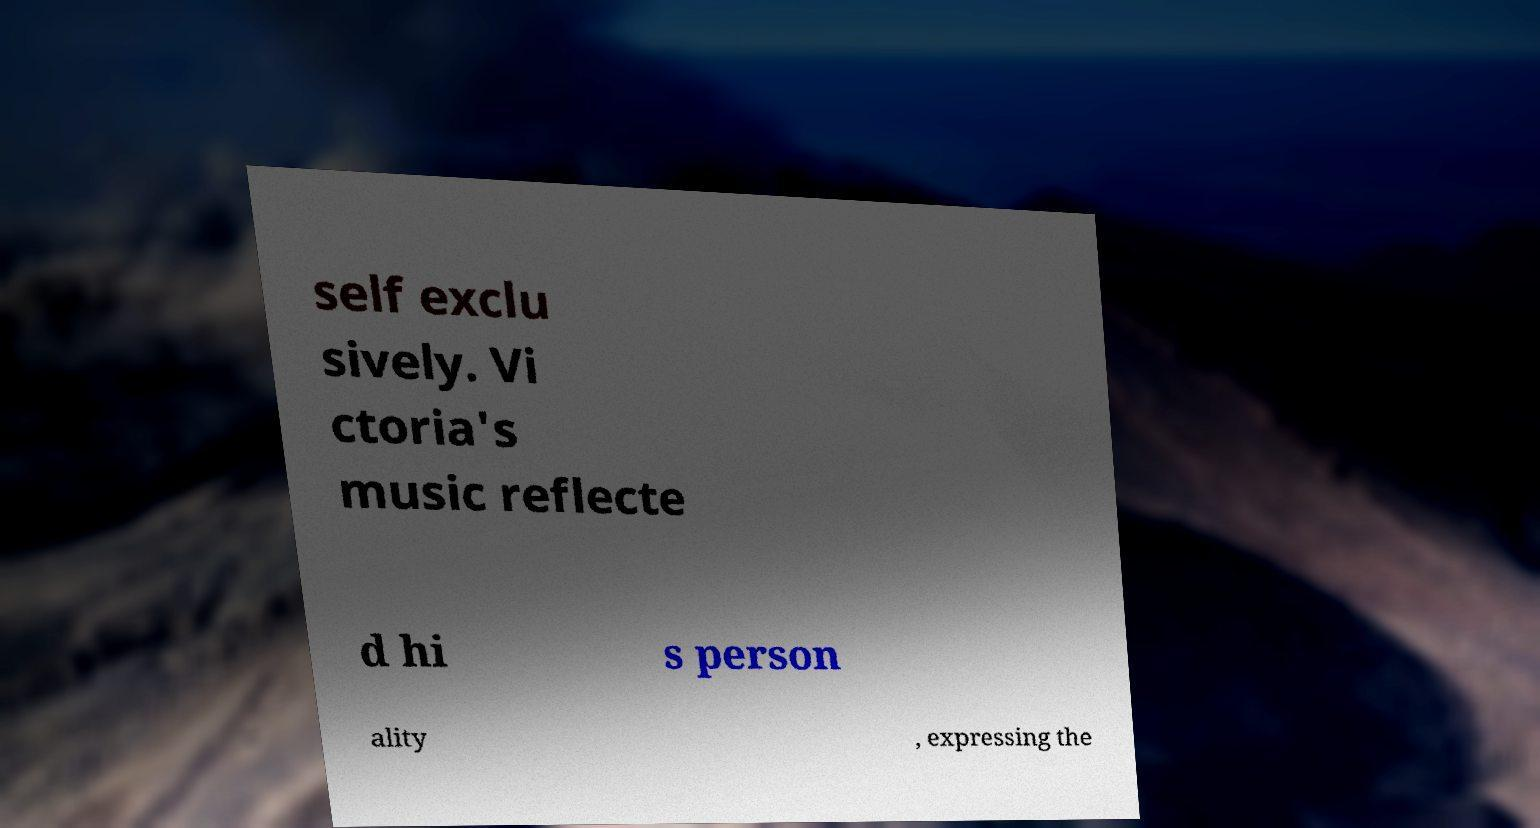Please read and relay the text visible in this image. What does it say? self exclu sively. Vi ctoria's music reflecte d hi s person ality , expressing the 